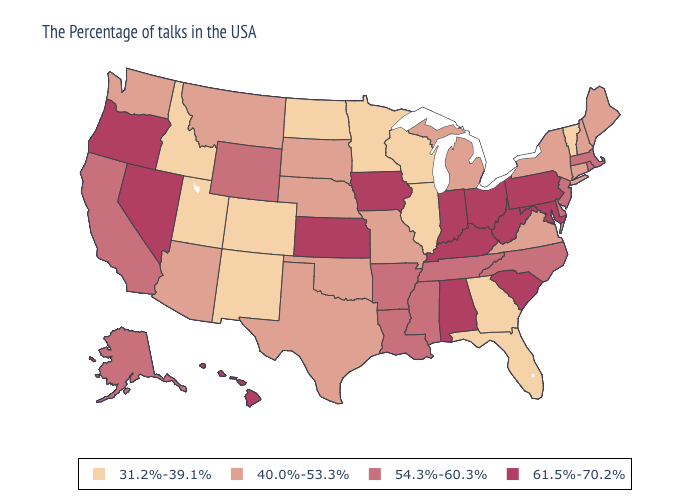What is the value of Missouri?
Short answer required. 40.0%-53.3%. Does New Jersey have a higher value than Wyoming?
Concise answer only. No. Name the states that have a value in the range 54.3%-60.3%?
Be succinct. Massachusetts, Rhode Island, New Jersey, Delaware, North Carolina, Tennessee, Mississippi, Louisiana, Arkansas, Wyoming, California, Alaska. Among the states that border Iowa , does Missouri have the lowest value?
Give a very brief answer. No. Among the states that border Florida , which have the lowest value?
Give a very brief answer. Georgia. Does Vermont have the highest value in the USA?
Concise answer only. No. Does Minnesota have the lowest value in the USA?
Write a very short answer. Yes. What is the lowest value in the USA?
Be succinct. 31.2%-39.1%. What is the value of New Jersey?
Write a very short answer. 54.3%-60.3%. Name the states that have a value in the range 40.0%-53.3%?
Concise answer only. Maine, New Hampshire, Connecticut, New York, Virginia, Michigan, Missouri, Nebraska, Oklahoma, Texas, South Dakota, Montana, Arizona, Washington. What is the value of Alaska?
Write a very short answer. 54.3%-60.3%. Does Oregon have the lowest value in the USA?
Answer briefly. No. Name the states that have a value in the range 61.5%-70.2%?
Be succinct. Maryland, Pennsylvania, South Carolina, West Virginia, Ohio, Kentucky, Indiana, Alabama, Iowa, Kansas, Nevada, Oregon, Hawaii. Name the states that have a value in the range 31.2%-39.1%?
Give a very brief answer. Vermont, Florida, Georgia, Wisconsin, Illinois, Minnesota, North Dakota, Colorado, New Mexico, Utah, Idaho. 